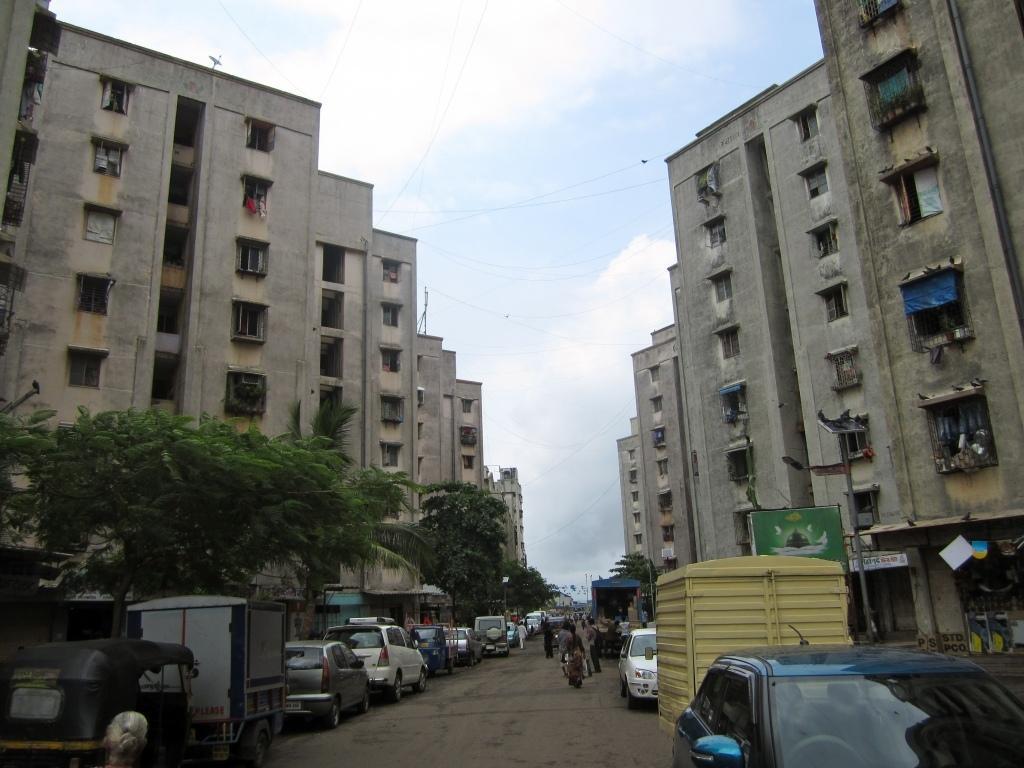Please provide a concise description of this image. In this picture there are few persons standing on the road and there are few vehicles,trees and buildings on either sides of them and there are few wires above the buildings and the sky is a bit cloudy. 